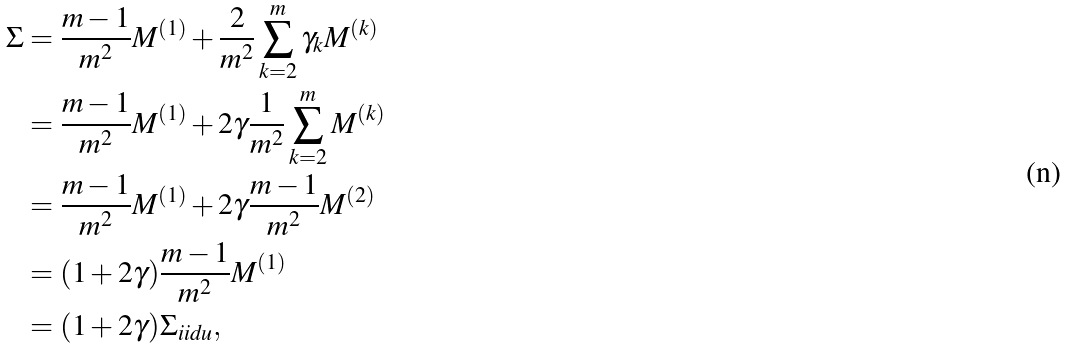Convert formula to latex. <formula><loc_0><loc_0><loc_500><loc_500>\Sigma & = \frac { m - 1 } { m ^ { 2 } } M ^ { ( 1 ) } + \frac { 2 } { m ^ { 2 } } \sum _ { k = 2 } ^ { m } \gamma _ { k } M ^ { ( k ) } \\ & = \frac { m - 1 } { m ^ { 2 } } M ^ { ( 1 ) } + 2 \gamma \frac { 1 } { m ^ { 2 } } \sum _ { k = 2 } ^ { m } M ^ { ( k ) } \\ & = \frac { m - 1 } { m ^ { 2 } } M ^ { ( 1 ) } + 2 \gamma \frac { m - 1 } { m ^ { 2 } } M ^ { ( 2 ) } \\ & = ( 1 + 2 \gamma ) \frac { m - 1 } { m ^ { 2 } } M ^ { ( 1 ) } \\ & = ( 1 + 2 \gamma ) \Sigma _ { i i d u } ,</formula> 